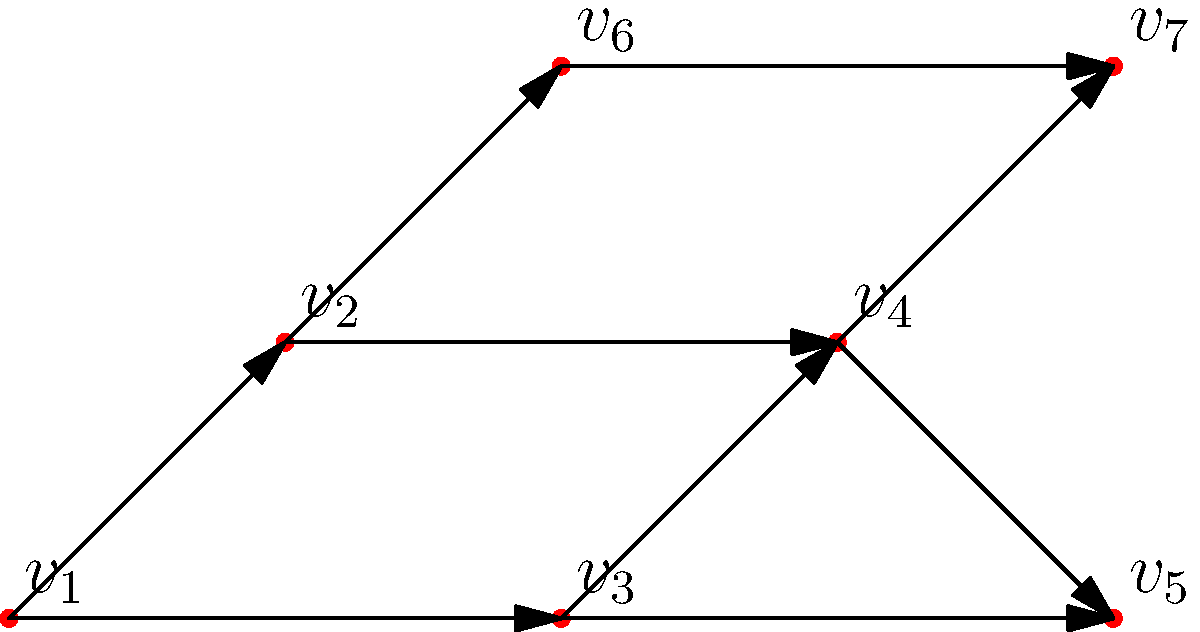In the directed acyclic graph (DAG) representing a gene regulatory network, which vertex has the highest out-degree and what biological interpretation could this have in the context of gene expression regulation? To answer this question, we need to follow these steps:

1. Understand the concept of out-degree in a directed graph:
   The out-degree of a vertex is the number of edges directed away from it.

2. Count the out-degree for each vertex:
   $v_1$: 2 edges (to $v_2$ and $v_3$)
   $v_2$: 2 edges (to $v_4$ and $v_5$)
   $v_3$: 2 edges (to $v_5$ and $v_7$)
   $v_4$: 1 edge (to $v_6$)
   $v_5$: 1 edge (to $v_6$)
   $v_6$: 1 edge (to $v_7$)
   $v_7$: 0 edges

3. Identify the vertex with the highest out-degree:
   Vertices $v_1$, $v_2$, and $v_3$ all have the highest out-degree of 2.

4. Biological interpretation:
   In a gene regulatory network, vertices typically represent genes or regulatory elements, while edges represent regulatory interactions. A vertex with a high out-degree suggests that the corresponding gene or regulatory element has a significant influence on multiple downstream targets.

   This could indicate:
   a) A master regulator gene that controls the expression of multiple other genes.
   b) A transcription factor binding site that affects the expression of multiple genes.
   c) A key regulatory element (e.g., enhancer) that modulates the activity of multiple genes in the network.

   The high out-degree vertices ($v_1$, $v_2$, and $v_3$) likely represent critical control points in the gene expression network, potentially serving as hubs for coordinating the expression of multiple genes or the activity of other regulatory elements.
Answer: $v_1$, $v_2$, and $v_3$ (out-degree: 2); potential master regulators or key regulatory elements 